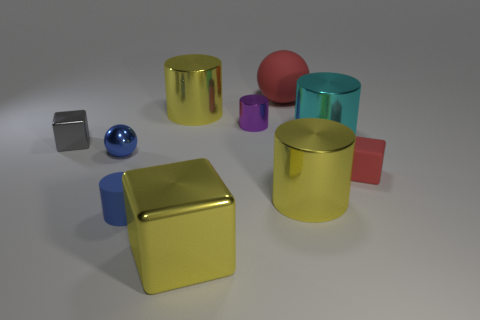How many tiny things are either red matte blocks or brown rubber blocks?
Offer a very short reply. 1. What is the color of the rubber sphere that is the same size as the cyan shiny cylinder?
Your answer should be very brief. Red. What number of other objects are the same shape as the big matte thing?
Ensure brevity in your answer.  1. Is there another red object that has the same material as the small red object?
Offer a very short reply. Yes. Are the red object behind the purple metal thing and the tiny block right of the big block made of the same material?
Your answer should be compact. Yes. What number of large metal objects are there?
Make the answer very short. 4. There is a tiny gray thing behind the yellow shiny cube; what shape is it?
Provide a short and direct response. Cube. What number of other objects are there of the same size as the rubber cube?
Your response must be concise. 4. Does the red thing behind the purple metallic thing have the same shape as the blue thing behind the tiny red matte block?
Your answer should be compact. Yes. There is a gray metal block; what number of small purple objects are right of it?
Your answer should be very brief. 1. 